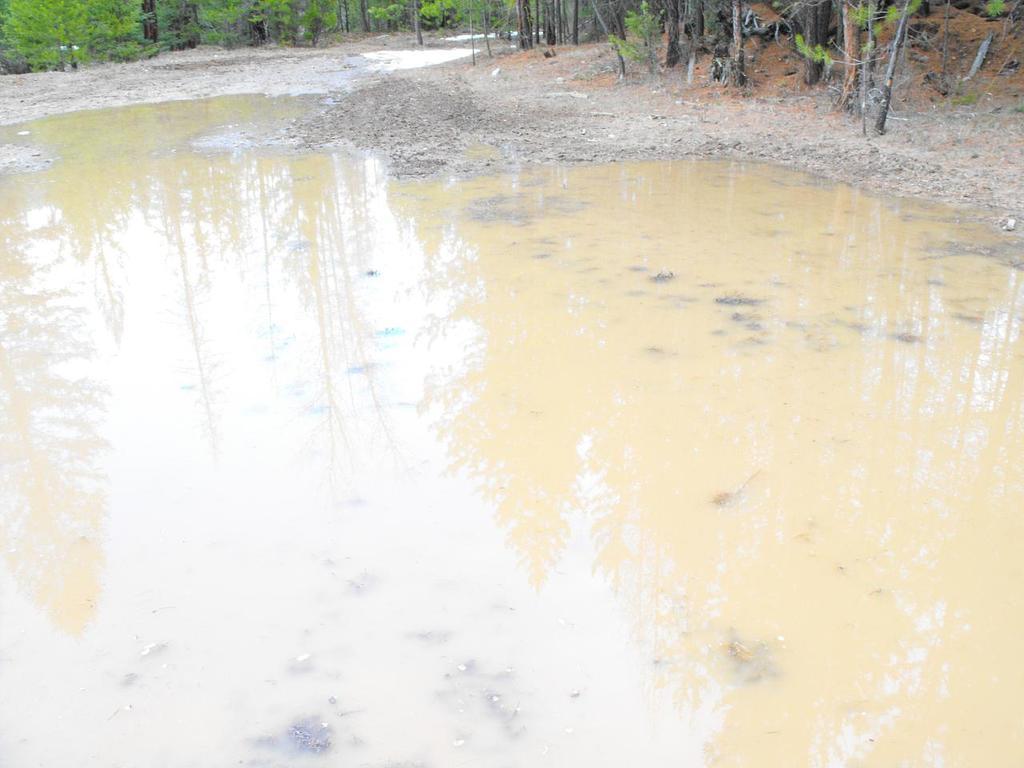Can you describe this image briefly? In this image we can see the road with the water. In the background we can see many trees. 